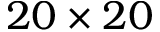Convert formula to latex. <formula><loc_0><loc_0><loc_500><loc_500>2 0 \times 2 0</formula> 